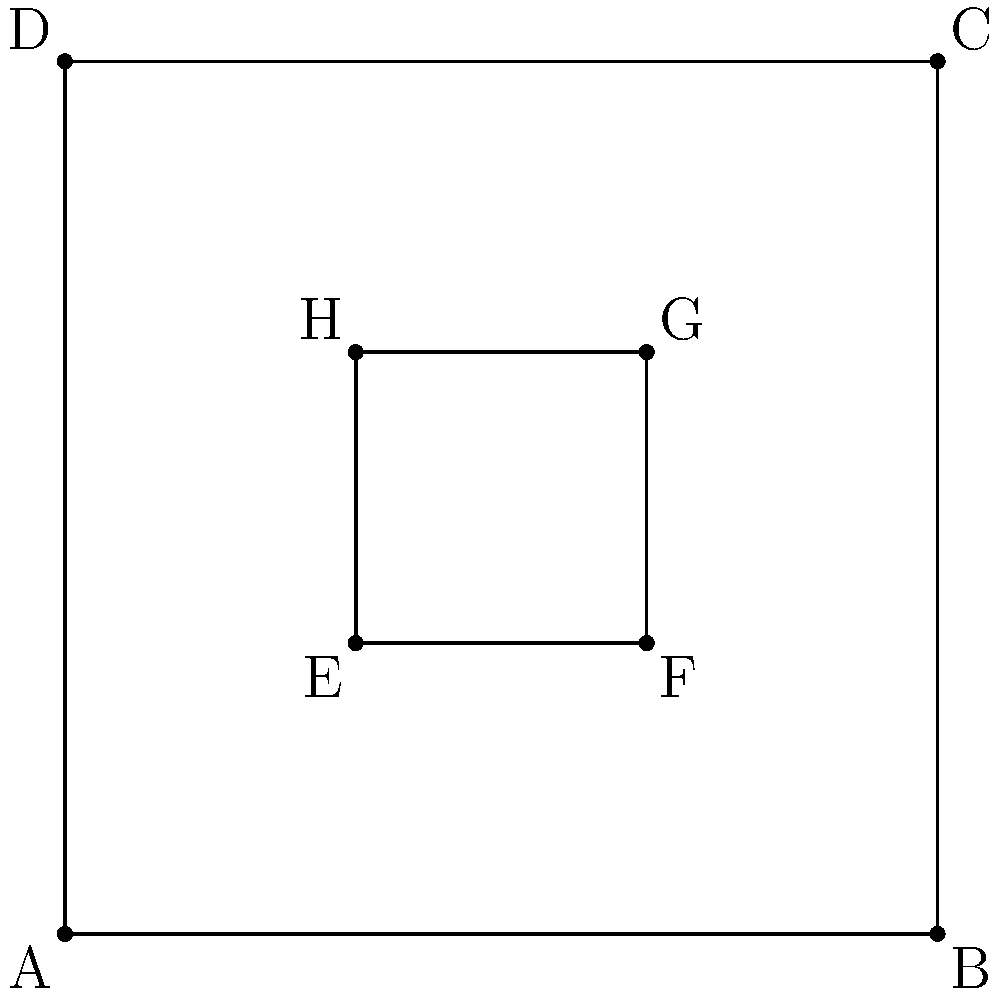As a Forró dance instructor, you're planning a workshop in a square-shaped room with side length 6 meters. You want to demonstrate a traditional Forró formation where couples form a smaller square within the room. If the inner square's corners are 2 meters from the room's walls (as shown in the diagram), what percentage of the total floor space is utilized by the dancers in the inner square formation? To solve this problem, let's follow these steps:

1. Calculate the area of the entire room:
   Area of room = $6m \times 6m = 36m^2$

2. Calculate the side length of the inner square:
   Inner square side = $6m - 2m - 2m = 2m$

3. Calculate the area of the inner square (dance formation):
   Area of dance formation = $2m \times 2m = 4m^2$

4. Calculate the percentage of floor space utilized:
   Percentage = $\frac{\text{Area of dance formation}}{\text{Area of room}} \times 100\%$
   
   $= \frac{4m^2}{36m^2} \times 100\%$
   
   $= \frac{1}{9} \times 100\%$
   
   $= 11.11\%$ (rounded to two decimal places)

Therefore, the dancers in the inner square formation utilize 11.11% of the total floor space.
Answer: 11.11% 